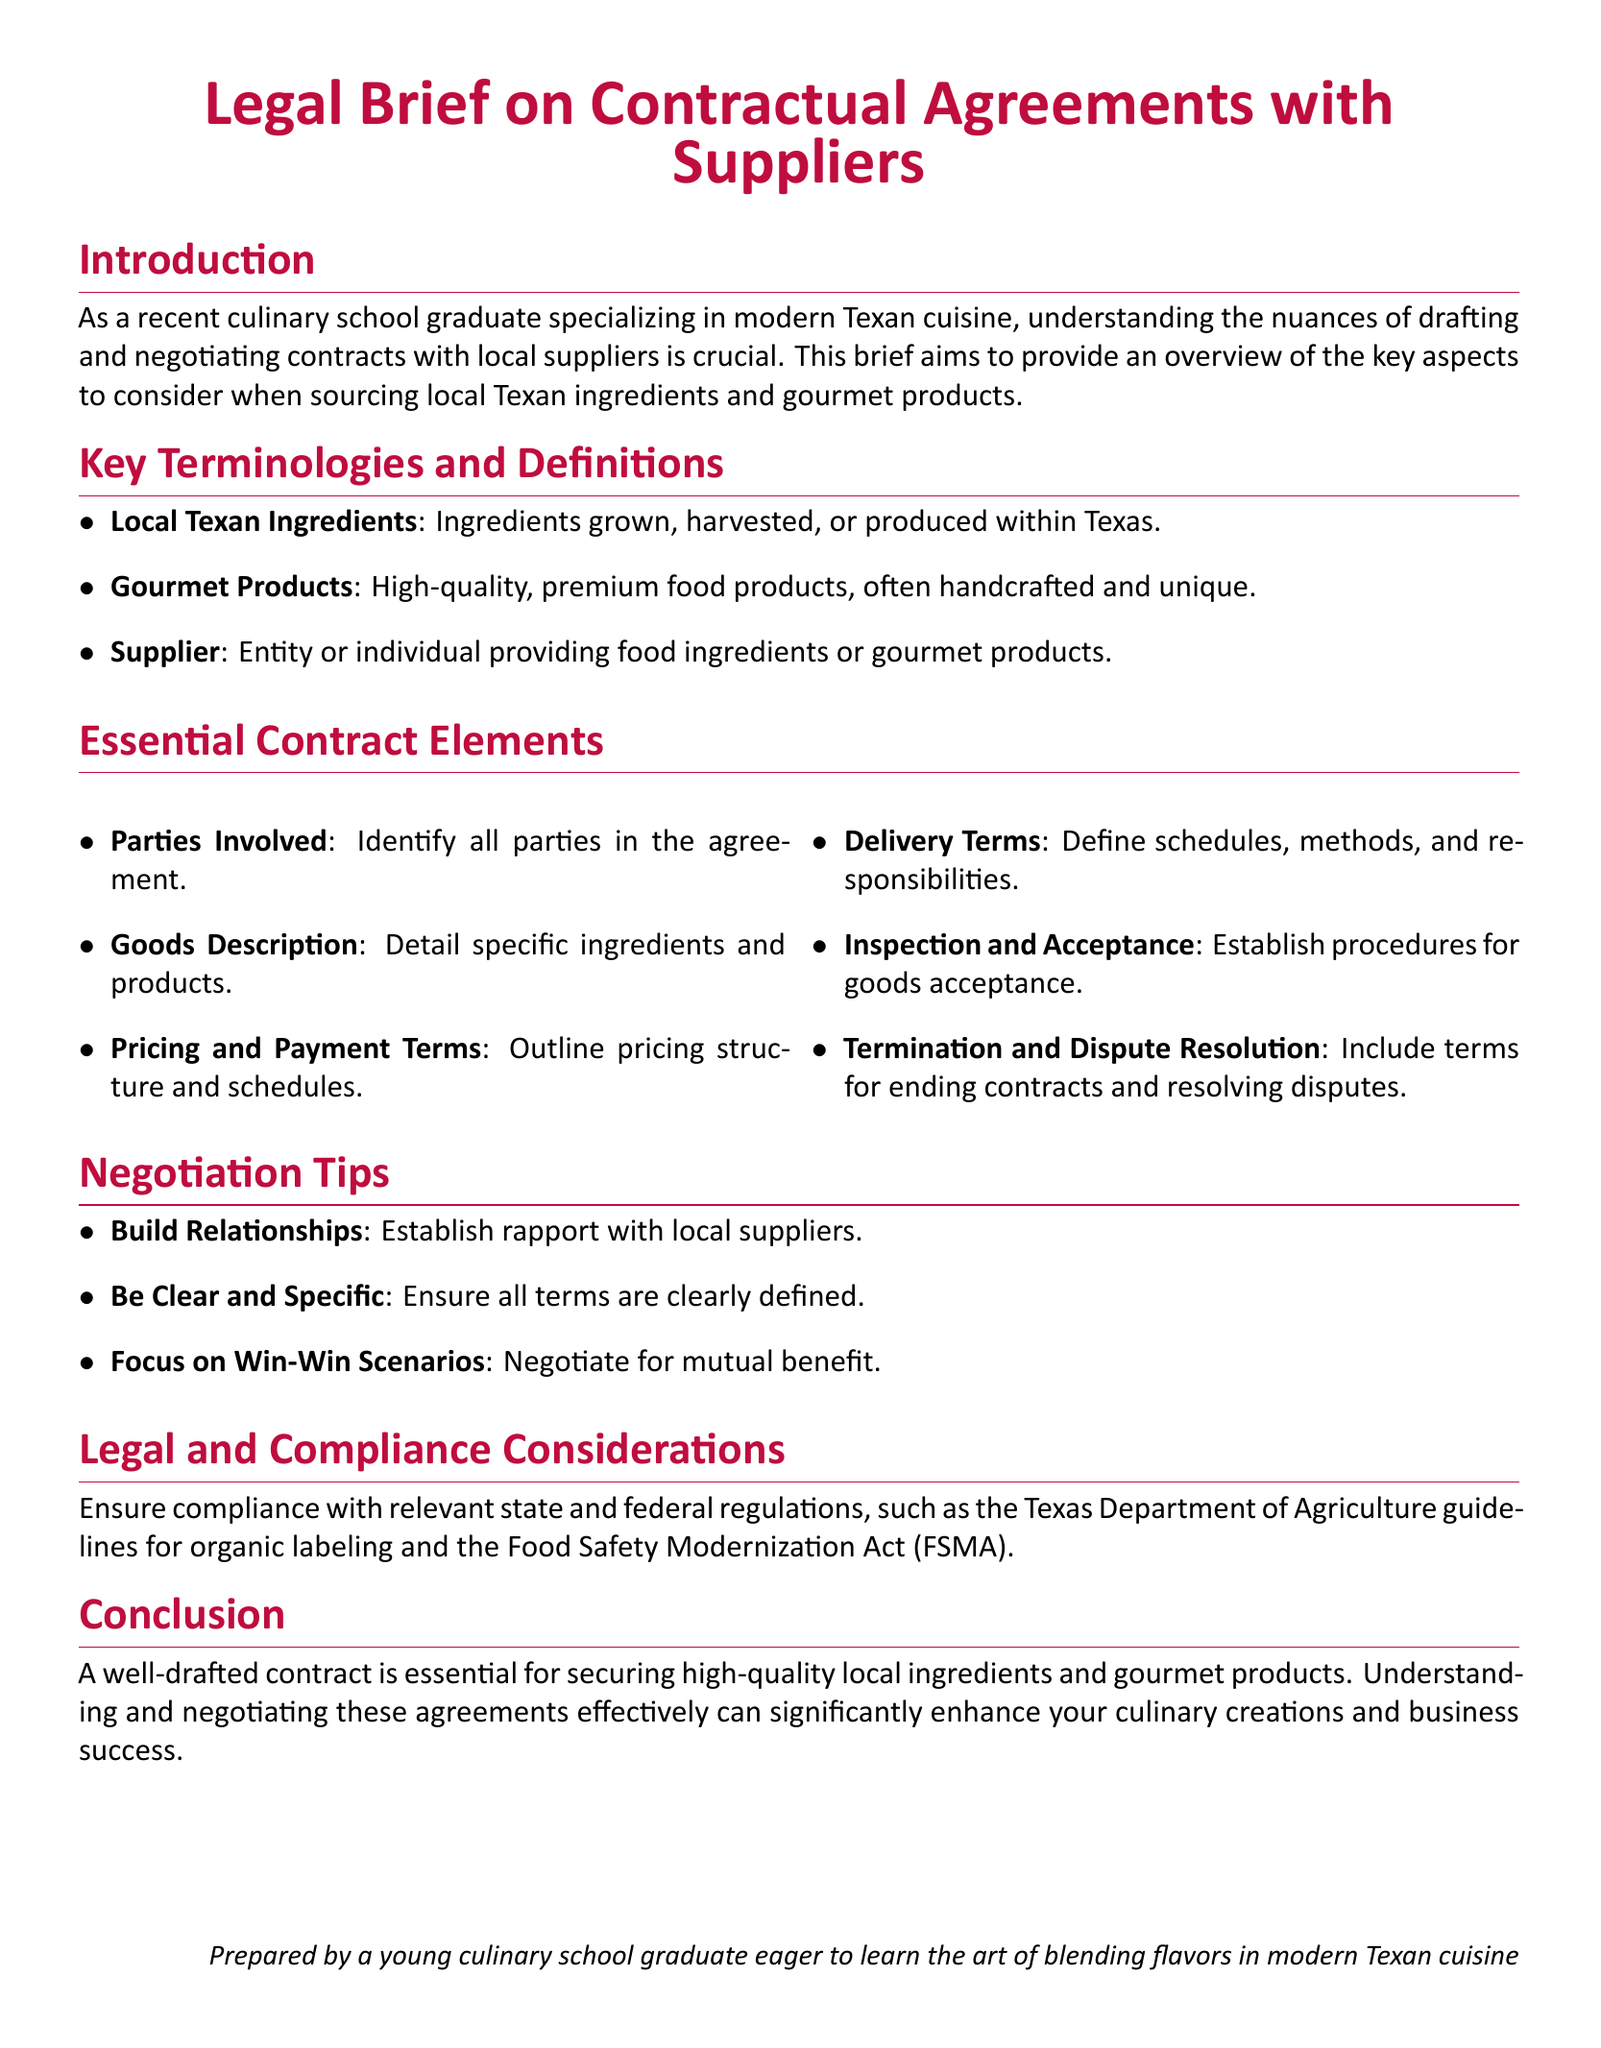what are local Texan ingredients? Local Texan ingredients refer to ingredients grown, harvested, or produced within Texas.
Answer: Ingredients grown, harvested, or produced within Texas what should be included in the goods description? Goods description should detail specific ingredients and products.
Answer: Specific ingredients and products what is a key consideration when negotiating contracts? A key consideration when negotiating contracts is to focus on win-win scenarios.
Answer: Focus on win-win scenarios what regulatory guidelines must suppliers comply with? Suppliers must ensure compliance with Texas Department of Agriculture guidelines and the Food Safety Modernization Act.
Answer: Texas Department of Agriculture guidelines and the Food Safety Modernization Act how many essential contract elements are mentioned? The document mentions six essential contract elements.
Answer: Six essential contract elements what is the document type? The document is a legal brief focused on contractual agreements with suppliers.
Answer: Legal brief who is the document prepared by? The document is prepared by a young culinary school graduate eager to learn.
Answer: A young culinary school graduate 